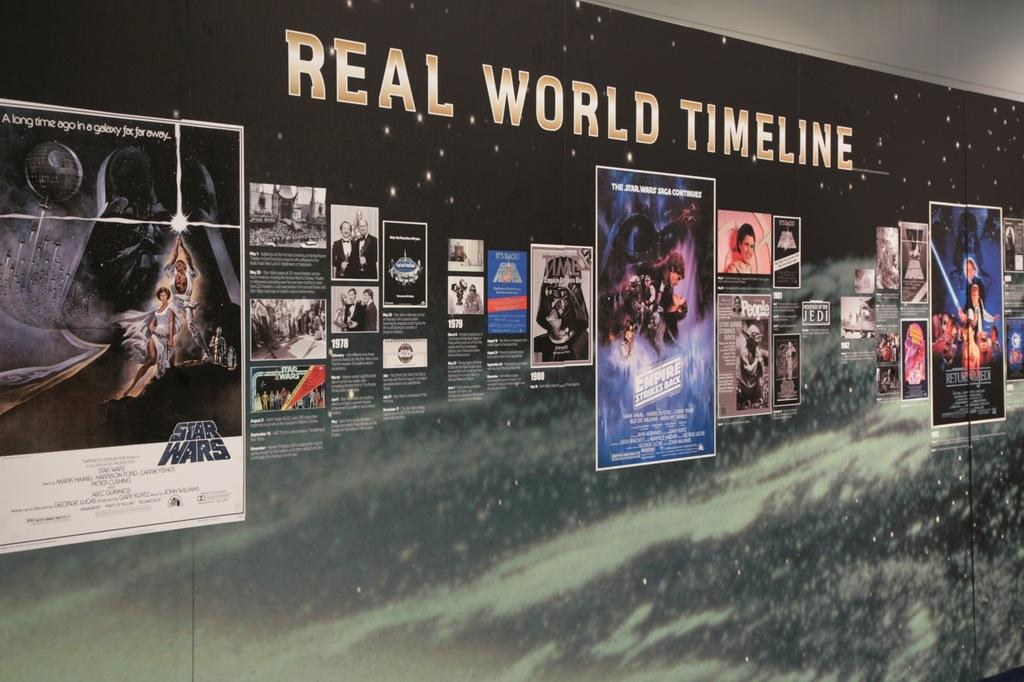<image>
Provide a brief description of the given image. A collage of posters of movies with "Real World Timeline" at the top. 